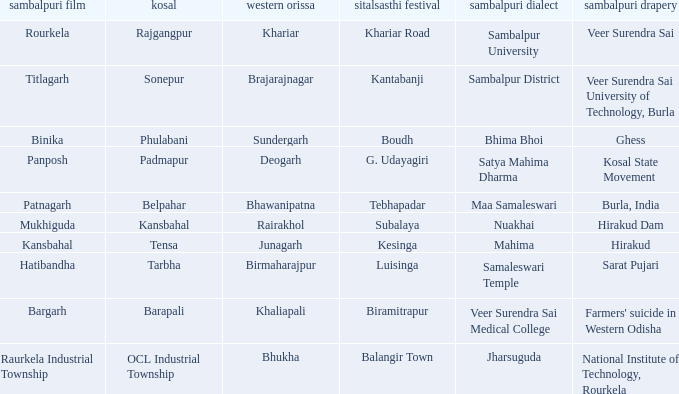What is the sitalsasthi carnival with sonepur as kosal? Kantabanji. Parse the full table. {'header': ['sambalpuri film', 'kosal', 'western orissa', 'sitalsasthi festival', 'sambalpuri dialect', 'sambalpuri drapery'], 'rows': [['Rourkela', 'Rajgangpur', 'Khariar', 'Khariar Road', 'Sambalpur University', 'Veer Surendra Sai'], ['Titlagarh', 'Sonepur', 'Brajarajnagar', 'Kantabanji', 'Sambalpur District', 'Veer Surendra Sai University of Technology, Burla'], ['Binika', 'Phulabani', 'Sundergarh', 'Boudh', 'Bhima Bhoi', 'Ghess'], ['Panposh', 'Padmapur', 'Deogarh', 'G. Udayagiri', 'Satya Mahima Dharma', 'Kosal State Movement'], ['Patnagarh', 'Belpahar', 'Bhawanipatna', 'Tebhapadar', 'Maa Samaleswari', 'Burla, India'], ['Mukhiguda', 'Kansbahal', 'Rairakhol', 'Subalaya', 'Nuakhai', 'Hirakud Dam'], ['Kansbahal', 'Tensa', 'Junagarh', 'Kesinga', 'Mahima', 'Hirakud'], ['Hatibandha', 'Tarbha', 'Birmaharajpur', 'Luisinga', 'Samaleswari Temple', 'Sarat Pujari'], ['Bargarh', 'Barapali', 'Khaliapali', 'Biramitrapur', 'Veer Surendra Sai Medical College', "Farmers' suicide in Western Odisha"], ['Raurkela Industrial Township', 'OCL Industrial Township', 'Bhukha', 'Balangir Town', 'Jharsuguda', 'National Institute of Technology, Rourkela']]} 